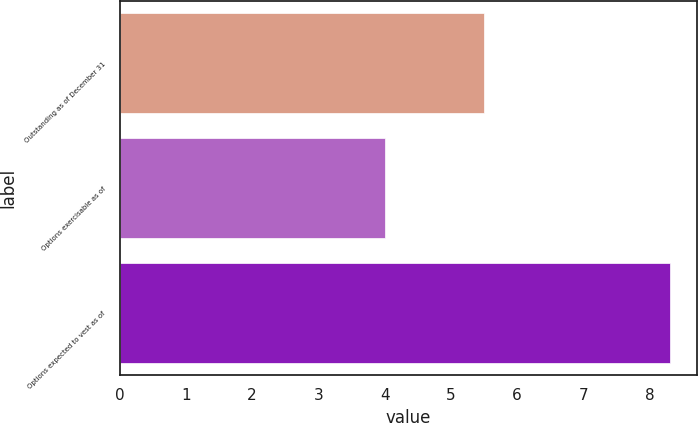<chart> <loc_0><loc_0><loc_500><loc_500><bar_chart><fcel>Outstanding as of December 31<fcel>Options exercisable as of<fcel>Options expected to vest as of<nl><fcel>5.5<fcel>4<fcel>8.3<nl></chart> 